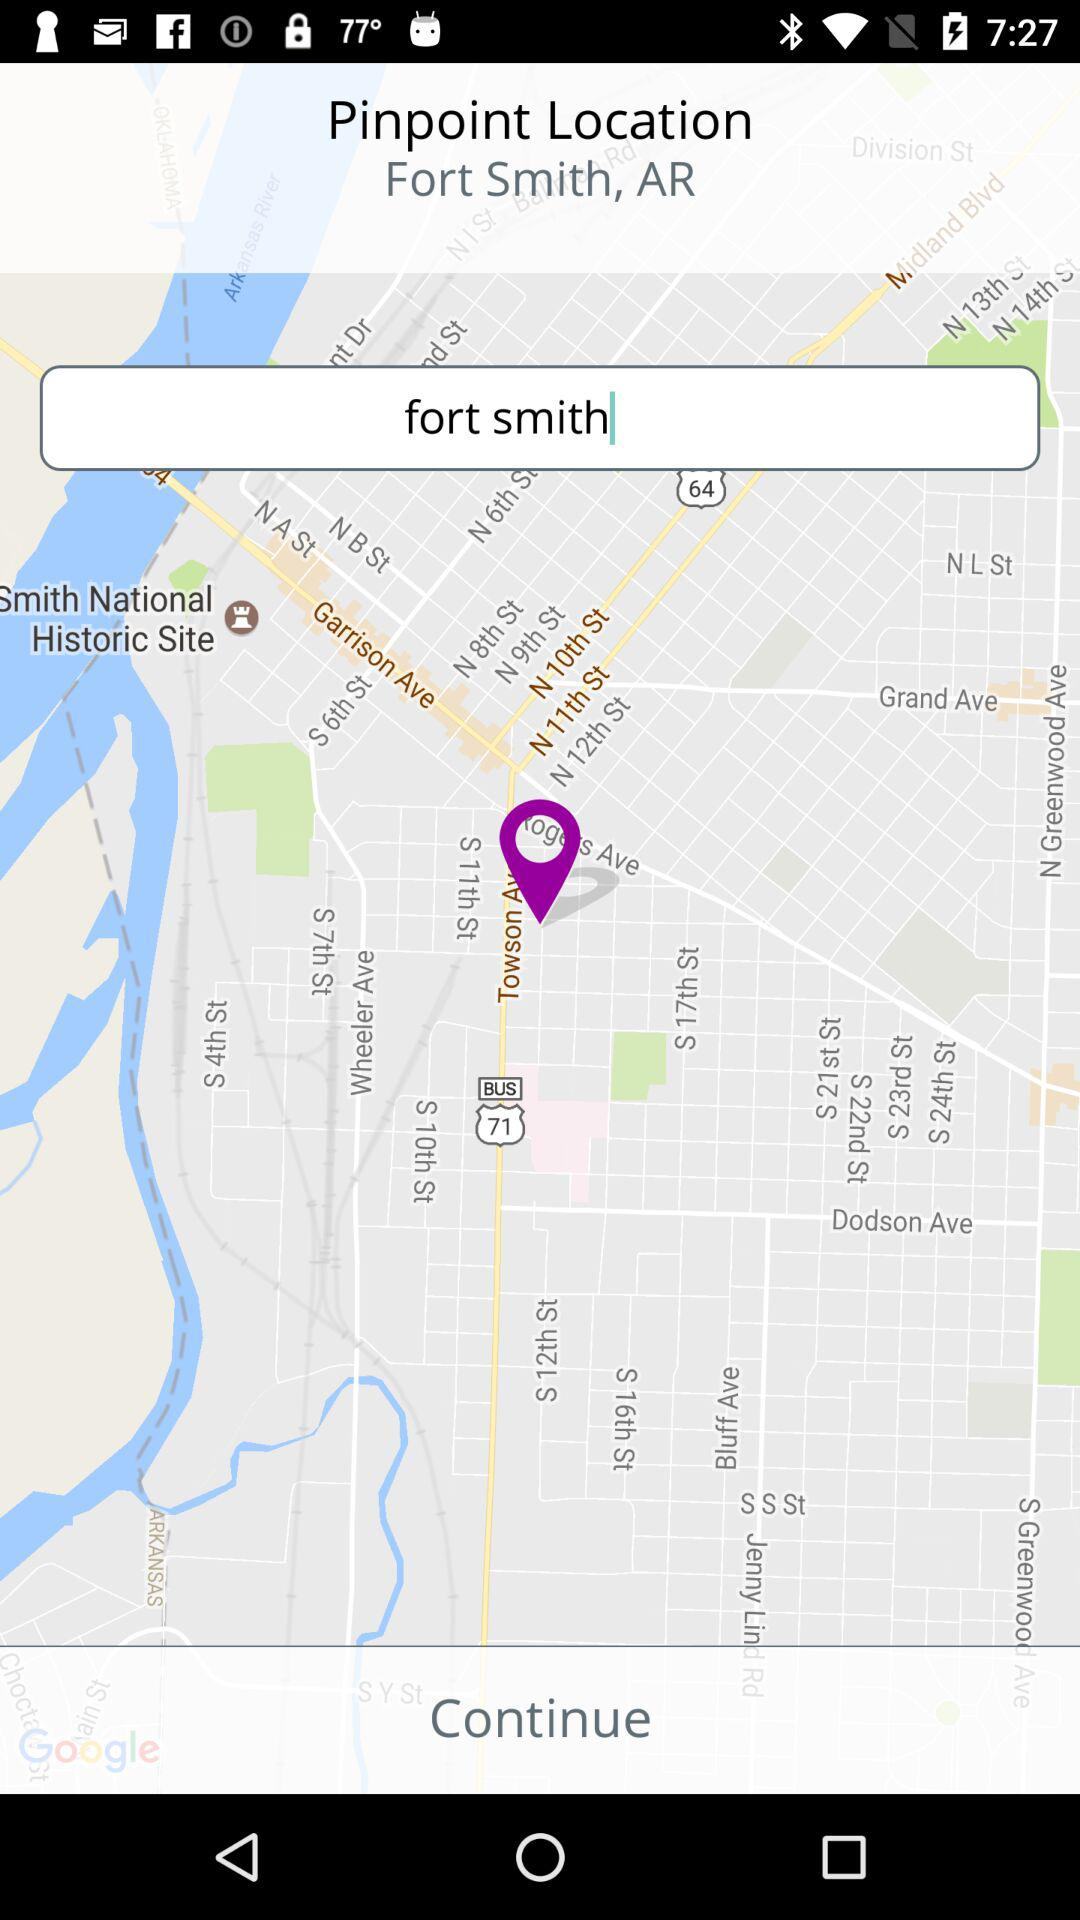What is the pinpoint location? The pinpoint location is Fort Smith, AR. 